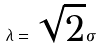<formula> <loc_0><loc_0><loc_500><loc_500>\lambda = \sqrt { 2 } \sigma</formula> 